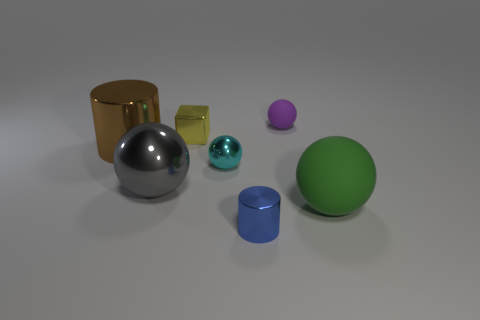Add 1 yellow objects. How many objects exist? 8 Subtract all brown cylinders. How many cylinders are left? 1 Subtract all cylinders. How many objects are left? 5 Subtract 1 cylinders. How many cylinders are left? 1 Add 4 gray spheres. How many gray spheres are left? 5 Add 3 tiny yellow objects. How many tiny yellow objects exist? 4 Subtract 0 yellow cylinders. How many objects are left? 7 Subtract all green cylinders. Subtract all cyan cubes. How many cylinders are left? 2 Subtract all rubber things. Subtract all yellow cubes. How many objects are left? 4 